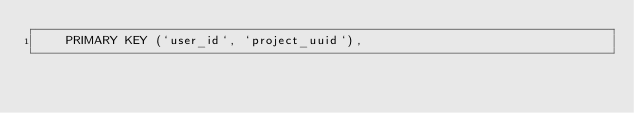<code> <loc_0><loc_0><loc_500><loc_500><_SQL_>    PRIMARY KEY (`user_id`, `project_uuid`),</code> 